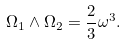<formula> <loc_0><loc_0><loc_500><loc_500>\Omega _ { 1 } \wedge \Omega _ { 2 } = \frac { 2 } { 3 } \omega ^ { 3 } .</formula> 